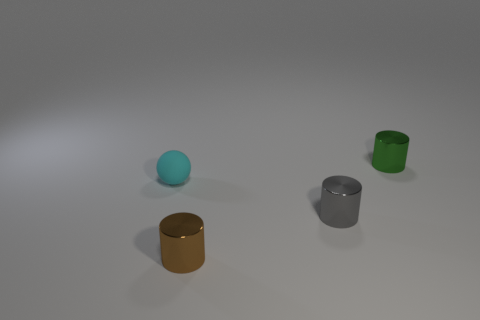What is the shape of the tiny thing that is behind the small cyan rubber object?
Give a very brief answer. Cylinder. What color is the shiny cylinder behind the thing left of the tiny brown metallic thing?
Give a very brief answer. Green. What number of rubber objects have the same color as the small ball?
Provide a succinct answer. 0. There is a small matte sphere; is it the same color as the shiny cylinder behind the sphere?
Your response must be concise. No. What is the shape of the thing that is on the left side of the small gray metal object and in front of the cyan matte thing?
Give a very brief answer. Cylinder. There is a tiny thing in front of the tiny gray thing that is to the right of the small object that is on the left side of the brown cylinder; what is its material?
Give a very brief answer. Metal. Are there more cyan rubber things that are in front of the small cyan rubber thing than tiny objects that are in front of the green metallic cylinder?
Keep it short and to the point. No. What number of other gray things are the same material as the gray thing?
Provide a succinct answer. 0. There is a metal thing in front of the small gray metal cylinder; is its shape the same as the metal object behind the gray object?
Keep it short and to the point. Yes. What is the color of the small cylinder behind the small cyan rubber object?
Provide a short and direct response. Green. 